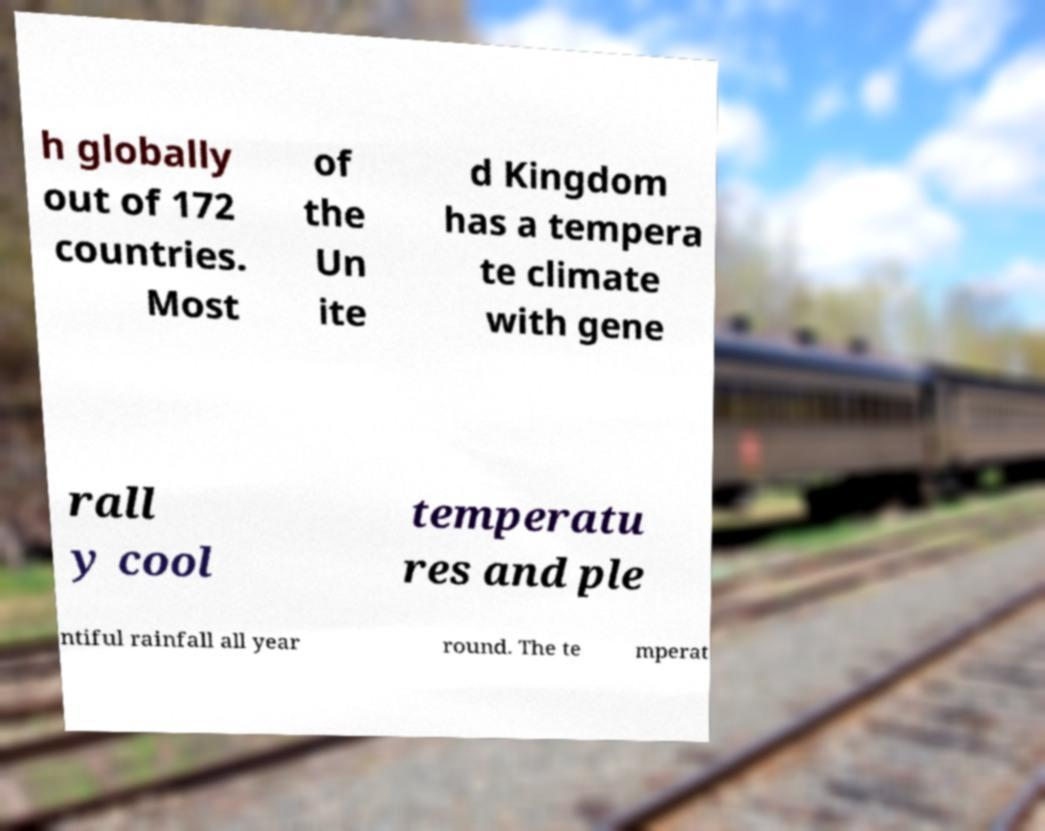Could you extract and type out the text from this image? h globally out of 172 countries. Most of the Un ite d Kingdom has a tempera te climate with gene rall y cool temperatu res and ple ntiful rainfall all year round. The te mperat 